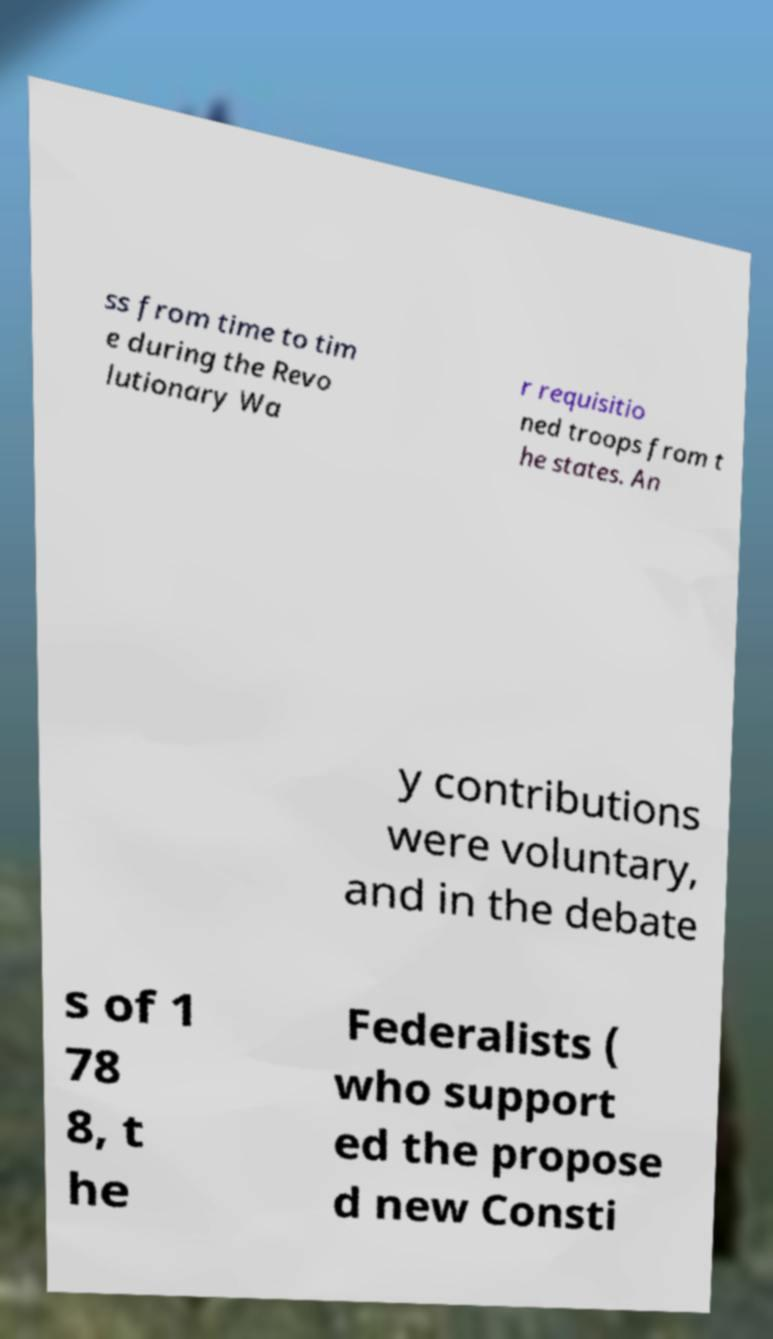What messages or text are displayed in this image? I need them in a readable, typed format. ss from time to tim e during the Revo lutionary Wa r requisitio ned troops from t he states. An y contributions were voluntary, and in the debate s of 1 78 8, t he Federalists ( who support ed the propose d new Consti 